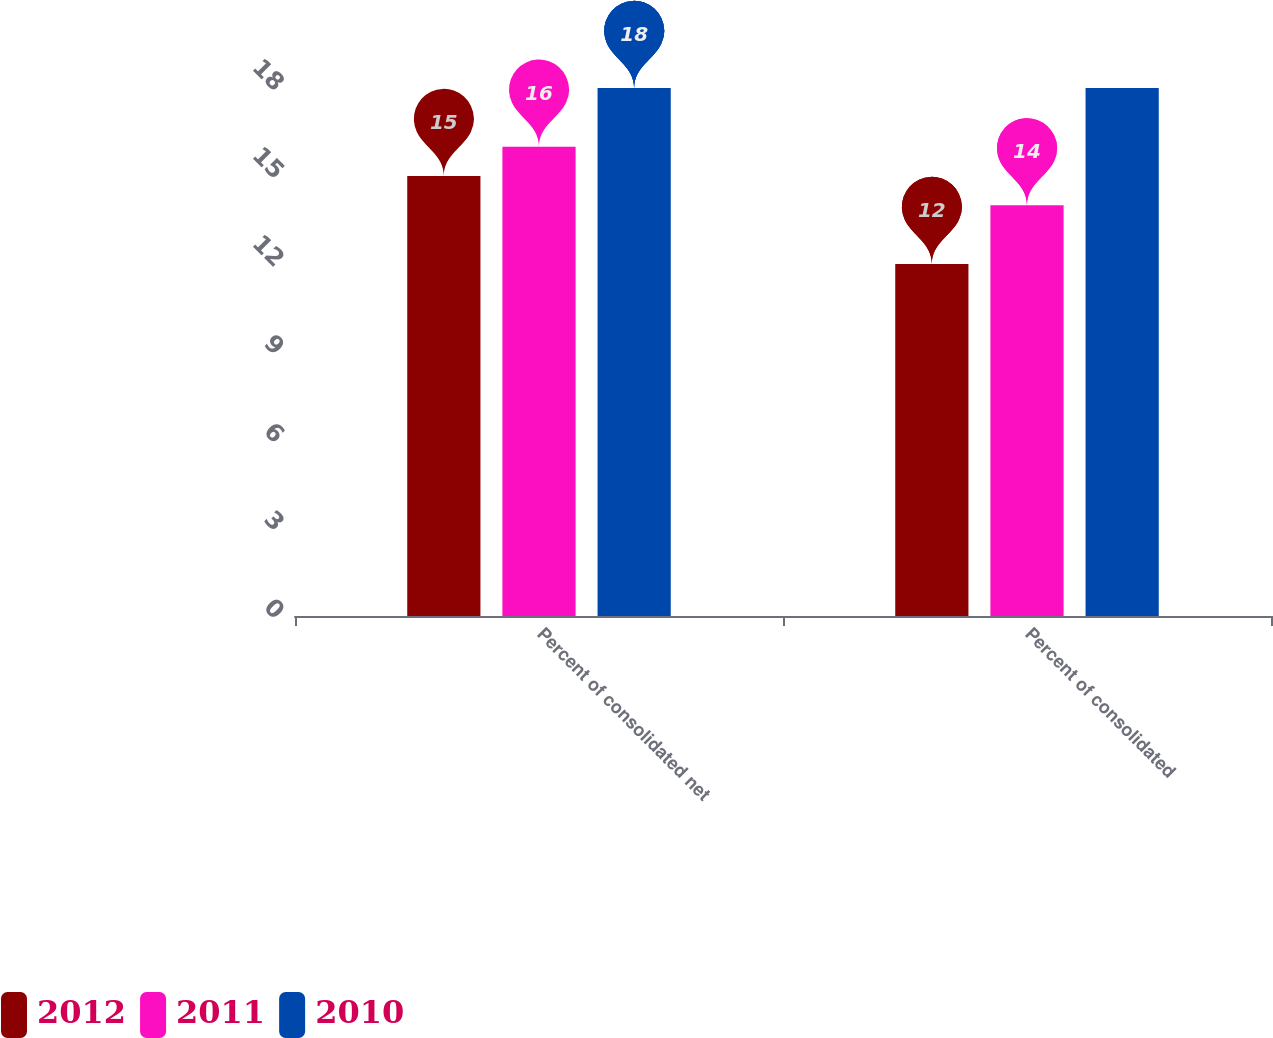<chart> <loc_0><loc_0><loc_500><loc_500><stacked_bar_chart><ecel><fcel>Percent of consolidated net<fcel>Percent of consolidated<nl><fcel>2012<fcel>15<fcel>12<nl><fcel>2011<fcel>16<fcel>14<nl><fcel>2010<fcel>18<fcel>18<nl></chart> 